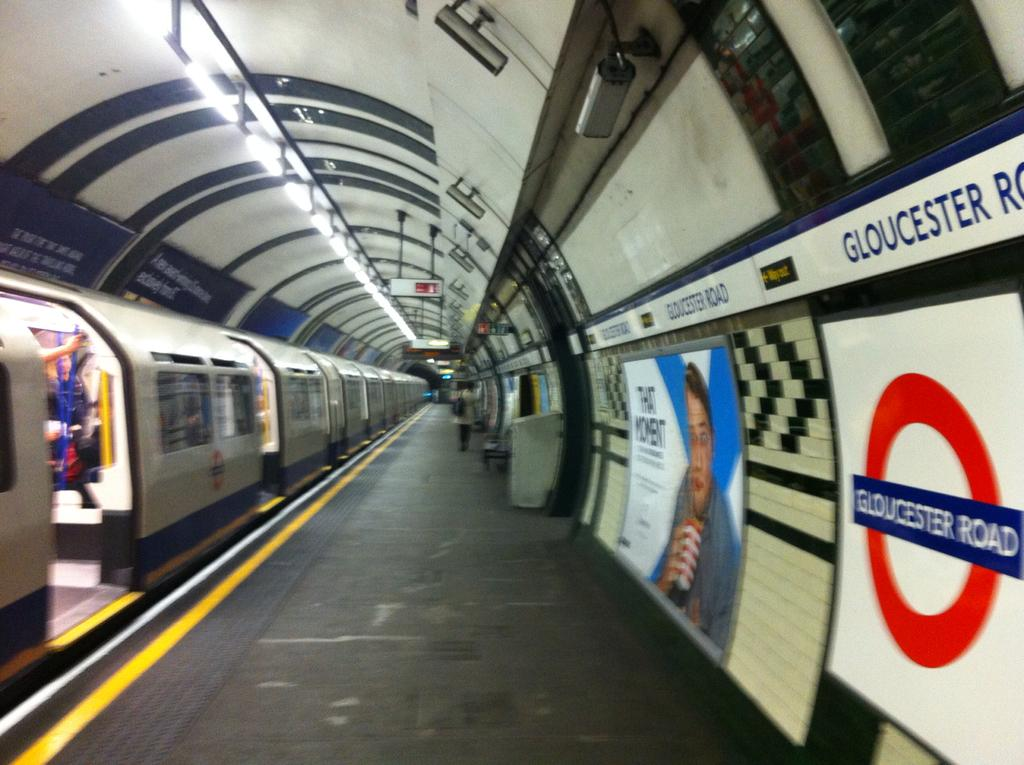<image>
Relay a brief, clear account of the picture shown. the word gloucester that is on a sign 